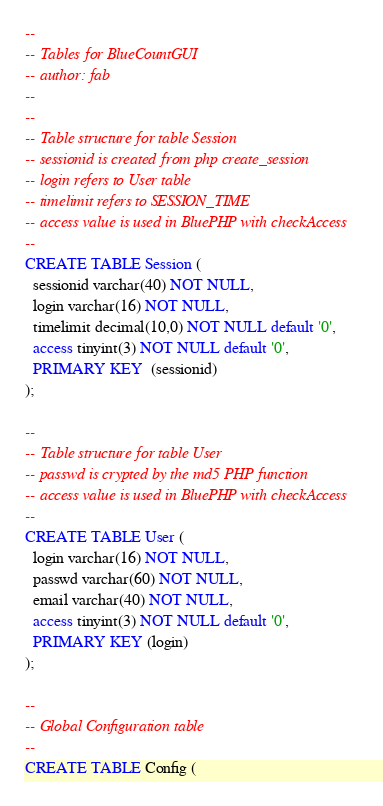<code> <loc_0><loc_0><loc_500><loc_500><_SQL_>--
-- Tables for BlueCountGUI
-- author: fab
--
--
-- Table structure for table Session
-- sessionid is created from php create_session
-- login refers to User table
-- timelimit refers to SESSION_TIME
-- access value is used in BluePHP with checkAccess
--
CREATE TABLE Session (
  sessionid varchar(40) NOT NULL,
  login varchar(16) NOT NULL,
  timelimit decimal(10,0) NOT NULL default '0',
  access tinyint(3) NOT NULL default '0',
  PRIMARY KEY  (sessionid)
);

--
-- Table structure for table User
-- passwd is crypted by the md5 PHP function
-- access value is used in BluePHP with checkAccess
--
CREATE TABLE User (
  login varchar(16) NOT NULL,
  passwd varchar(60) NOT NULL,
  email varchar(40) NOT NULL,
  access tinyint(3) NOT NULL default '0',
  PRIMARY KEY (login)
);

--
-- Global Configuration table
--
CREATE TABLE Config (</code> 